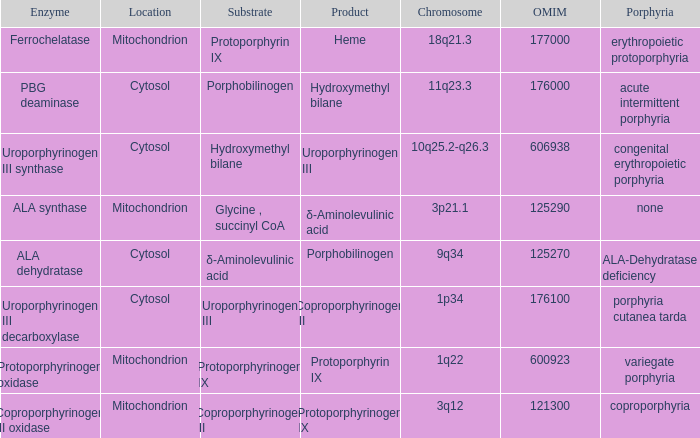What is the location of the enzyme Uroporphyrinogen iii Synthase? Cytosol. 